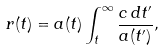Convert formula to latex. <formula><loc_0><loc_0><loc_500><loc_500>r ( t ) = a ( t ) \int _ { t } ^ { \infty } \frac { c \, d t ^ { \prime } } { a ( t ^ { \prime } ) } ,</formula> 